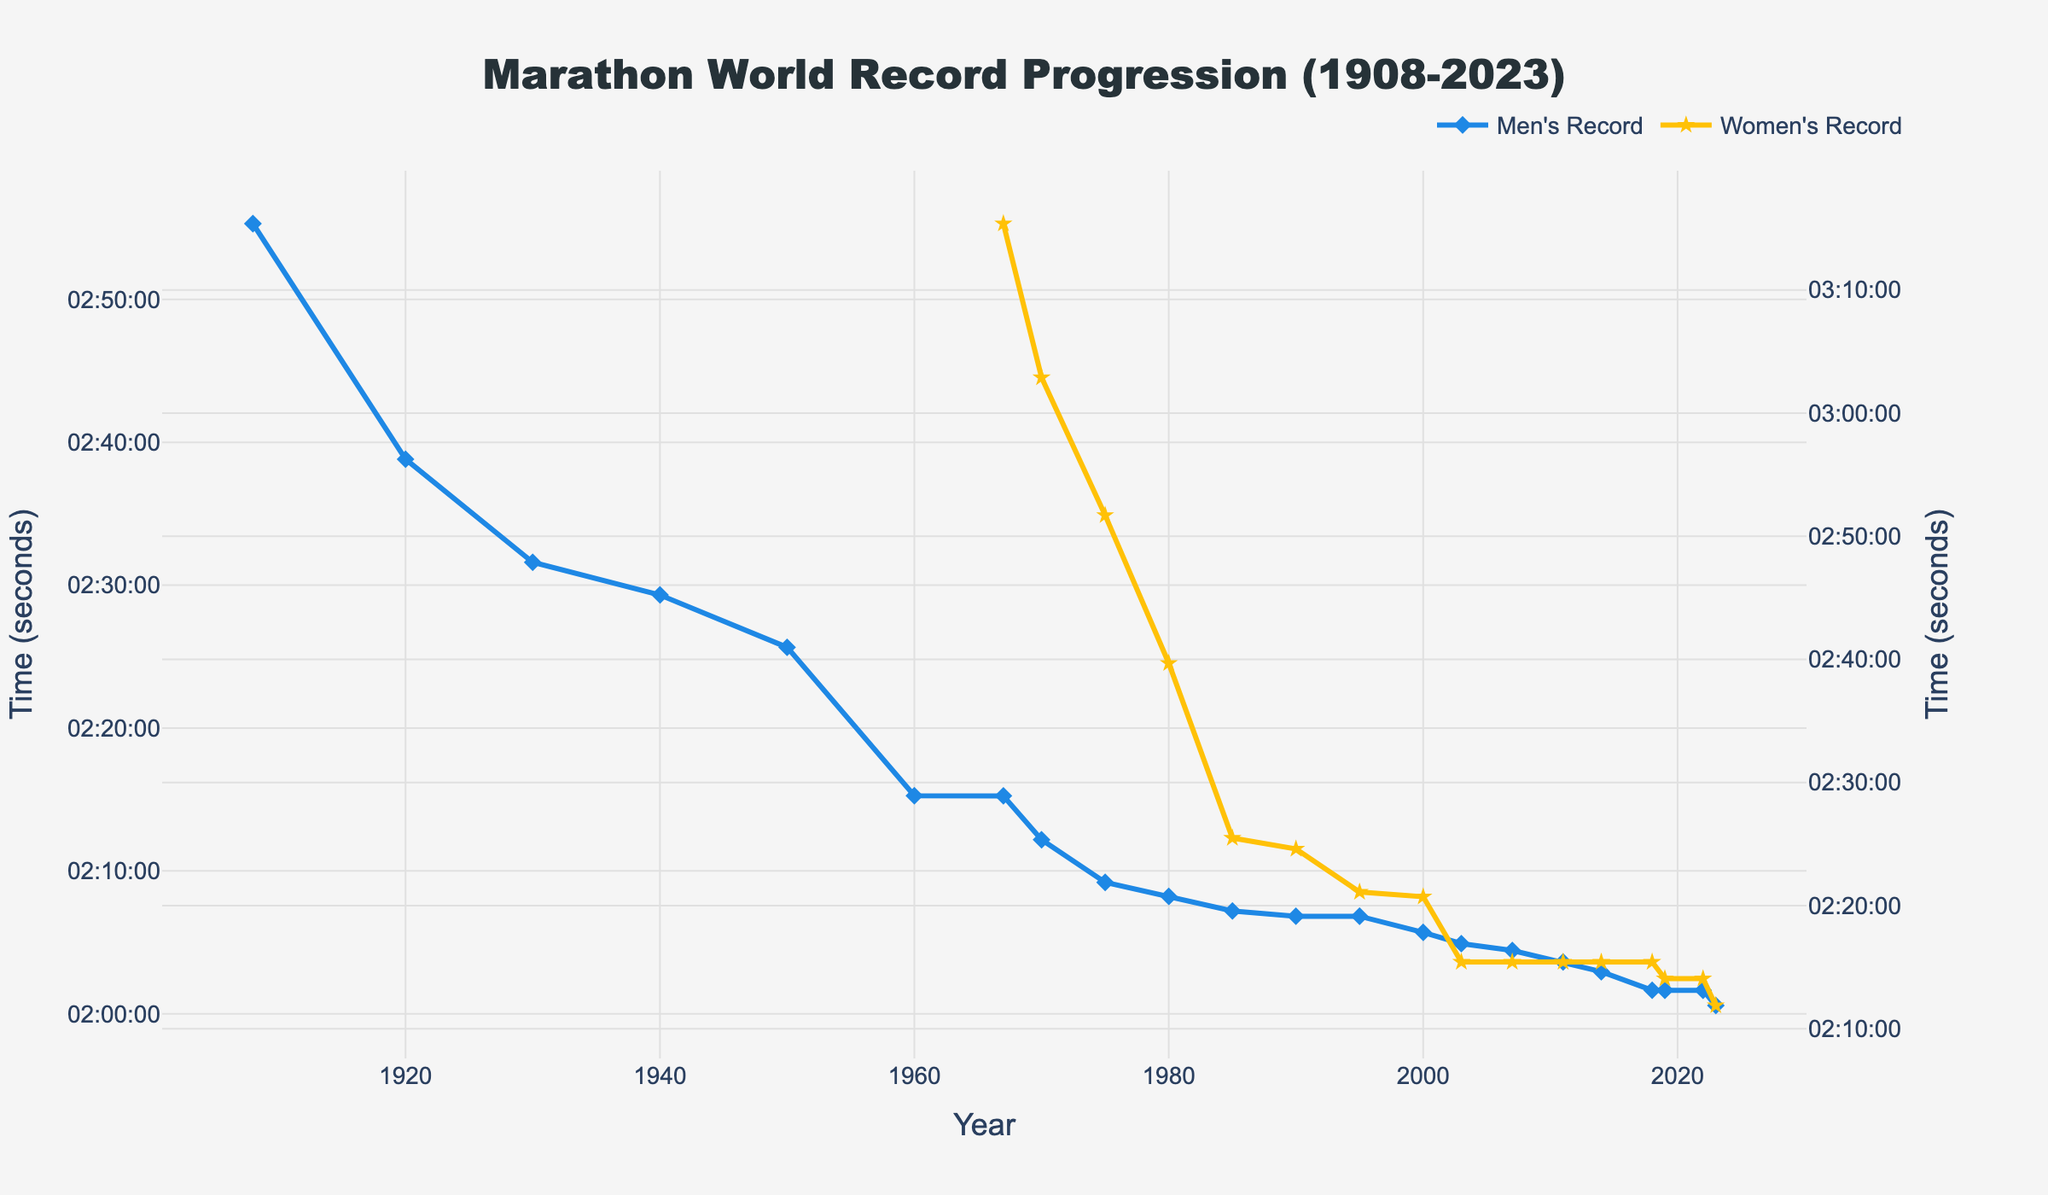What's the fastest Men's marathon world record time displayed on the graph? The fastest Men's marathon time can be identified by looking at the lowest point on the Men's Record line. The lowest point on the graph is at 2023, with a time of 2:00:35.
Answer: 2:00:35 What's the difference between the Men's and Women's marathon world record times in 2023? Find the Men's time (2:00:35) and Women's time (2:11:53) in 2023, then convert these times to seconds. The Men's time is (2*3600 + 0*60 + 35) = 7235 seconds, and the Women's time is (2*3600 + 11*60 + 53) = 7913 seconds. The difference is 7913 - 7235 = 678 seconds. Convert it back to h:mm:ss form, which is 0:11:18.
Answer: 0:11:18 In which year did the Women's record drop to below 2:30:00? Look at the Women's Record line and find the first point where the time is below 2:30:00. This occurs in 1985 with a time of 2:25:29.
Answer: 1985 How many years did it take for the Men's record to improve from around 2:15:00 to around 2:05:00? Find the years where the Men's times were approximately 2:15:00 and 2:05:00. In 1967, the time is 2:15:15, and in 2000, the time is 2:05:42. The difference is 2000 - 1967 = 33 years.
Answer: 33 years Which gender showed no improvement in their record time from 2011 to 2018? Look for the period from 2011 to 2018, and compare the lines of both genders. The Women's line is flat, indicating that there was no improvement during that period, while the Men's line shows improvement.
Answer: Women's How much did the Men's marathon record improve from the earliest year shown to the most recent year shown? Find the times for both 1908 (2:55:18) and 2023 (2:00:35). Convert these times to seconds: 2:55:18 is (2*3600 + 55*60 + 18) = 10518 seconds, and 2:00:35 is 7235 seconds. The improvement is 10518 - 7235 = 3283 seconds. Convert back to h:mm:ss, which is 0:54:43.
Answer: 0:54:43 What is the average improvement rate of the Women's marathon record per decade from 1967 to 1980? Find the Women's times in 1967 (3:15:23) and 1980 (2:39:41). Convert to seconds: 3:15:23 is (3*3600 + 15*60 + 23) = 11723 seconds, and 2:39:41 is 9581 seconds. The improvement is 11723 - 9581 = 2142 seconds over 13 years. Average rate per decade = (2142 / 13) * 10 ≈ 1647.69 seconds.
Answer: 1647.69 seconds Calculate the percentage improvement in the Women's marathon record from 1967 to 2023. Find the Women's times in 1967 (3:15:23) and 2023 (2:11:53). Convert to seconds: 3:15:23 is 11723 seconds, and 2:11:53 is 7913 seconds. The improvement is 11723 - 7913 = 3810 seconds. The percentage improvement = (3810 / 11723) * 100 ≈ 32.5%.
Answer: 32.5% 